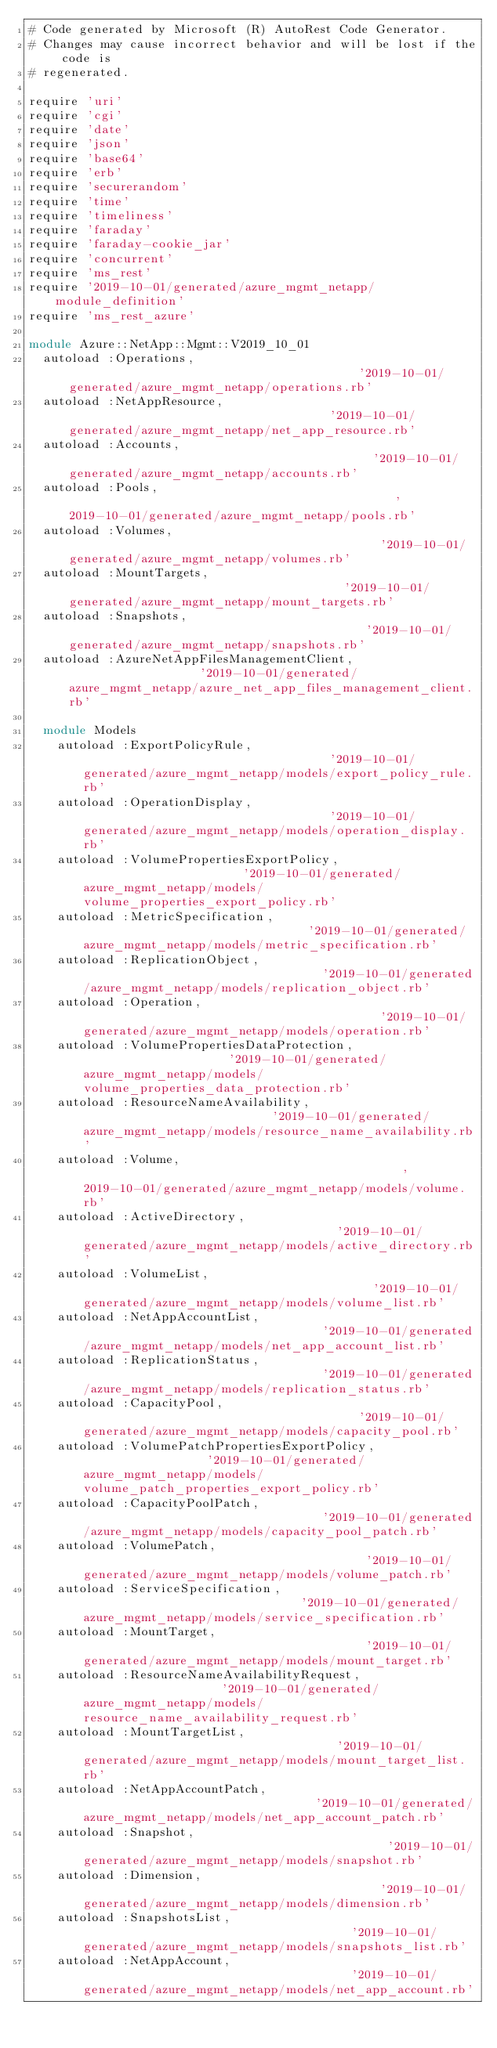<code> <loc_0><loc_0><loc_500><loc_500><_Ruby_># Code generated by Microsoft (R) AutoRest Code Generator.
# Changes may cause incorrect behavior and will be lost if the code is
# regenerated.

require 'uri'
require 'cgi'
require 'date'
require 'json'
require 'base64'
require 'erb'
require 'securerandom'
require 'time'
require 'timeliness'
require 'faraday'
require 'faraday-cookie_jar'
require 'concurrent'
require 'ms_rest'
require '2019-10-01/generated/azure_mgmt_netapp/module_definition'
require 'ms_rest_azure'

module Azure::NetApp::Mgmt::V2019_10_01
  autoload :Operations,                                         '2019-10-01/generated/azure_mgmt_netapp/operations.rb'
  autoload :NetAppResource,                                     '2019-10-01/generated/azure_mgmt_netapp/net_app_resource.rb'
  autoload :Accounts,                                           '2019-10-01/generated/azure_mgmt_netapp/accounts.rb'
  autoload :Pools,                                              '2019-10-01/generated/azure_mgmt_netapp/pools.rb'
  autoload :Volumes,                                            '2019-10-01/generated/azure_mgmt_netapp/volumes.rb'
  autoload :MountTargets,                                       '2019-10-01/generated/azure_mgmt_netapp/mount_targets.rb'
  autoload :Snapshots,                                          '2019-10-01/generated/azure_mgmt_netapp/snapshots.rb'
  autoload :AzureNetAppFilesManagementClient,                   '2019-10-01/generated/azure_mgmt_netapp/azure_net_app_files_management_client.rb'

  module Models
    autoload :ExportPolicyRule,                                   '2019-10-01/generated/azure_mgmt_netapp/models/export_policy_rule.rb'
    autoload :OperationDisplay,                                   '2019-10-01/generated/azure_mgmt_netapp/models/operation_display.rb'
    autoload :VolumePropertiesExportPolicy,                       '2019-10-01/generated/azure_mgmt_netapp/models/volume_properties_export_policy.rb'
    autoload :MetricSpecification,                                '2019-10-01/generated/azure_mgmt_netapp/models/metric_specification.rb'
    autoload :ReplicationObject,                                  '2019-10-01/generated/azure_mgmt_netapp/models/replication_object.rb'
    autoload :Operation,                                          '2019-10-01/generated/azure_mgmt_netapp/models/operation.rb'
    autoload :VolumePropertiesDataProtection,                     '2019-10-01/generated/azure_mgmt_netapp/models/volume_properties_data_protection.rb'
    autoload :ResourceNameAvailability,                           '2019-10-01/generated/azure_mgmt_netapp/models/resource_name_availability.rb'
    autoload :Volume,                                             '2019-10-01/generated/azure_mgmt_netapp/models/volume.rb'
    autoload :ActiveDirectory,                                    '2019-10-01/generated/azure_mgmt_netapp/models/active_directory.rb'
    autoload :VolumeList,                                         '2019-10-01/generated/azure_mgmt_netapp/models/volume_list.rb'
    autoload :NetAppAccountList,                                  '2019-10-01/generated/azure_mgmt_netapp/models/net_app_account_list.rb'
    autoload :ReplicationStatus,                                  '2019-10-01/generated/azure_mgmt_netapp/models/replication_status.rb'
    autoload :CapacityPool,                                       '2019-10-01/generated/azure_mgmt_netapp/models/capacity_pool.rb'
    autoload :VolumePatchPropertiesExportPolicy,                  '2019-10-01/generated/azure_mgmt_netapp/models/volume_patch_properties_export_policy.rb'
    autoload :CapacityPoolPatch,                                  '2019-10-01/generated/azure_mgmt_netapp/models/capacity_pool_patch.rb'
    autoload :VolumePatch,                                        '2019-10-01/generated/azure_mgmt_netapp/models/volume_patch.rb'
    autoload :ServiceSpecification,                               '2019-10-01/generated/azure_mgmt_netapp/models/service_specification.rb'
    autoload :MountTarget,                                        '2019-10-01/generated/azure_mgmt_netapp/models/mount_target.rb'
    autoload :ResourceNameAvailabilityRequest,                    '2019-10-01/generated/azure_mgmt_netapp/models/resource_name_availability_request.rb'
    autoload :MountTargetList,                                    '2019-10-01/generated/azure_mgmt_netapp/models/mount_target_list.rb'
    autoload :NetAppAccountPatch,                                 '2019-10-01/generated/azure_mgmt_netapp/models/net_app_account_patch.rb'
    autoload :Snapshot,                                           '2019-10-01/generated/azure_mgmt_netapp/models/snapshot.rb'
    autoload :Dimension,                                          '2019-10-01/generated/azure_mgmt_netapp/models/dimension.rb'
    autoload :SnapshotsList,                                      '2019-10-01/generated/azure_mgmt_netapp/models/snapshots_list.rb'
    autoload :NetAppAccount,                                      '2019-10-01/generated/azure_mgmt_netapp/models/net_app_account.rb'</code> 